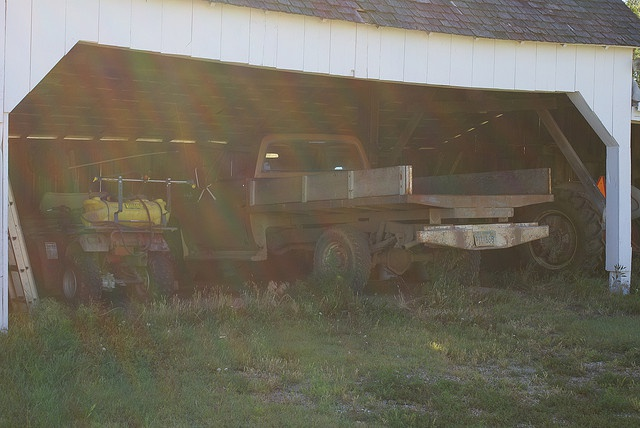Describe the objects in this image and their specific colors. I can see truck in lightgray, gray, and darkgray tones and truck in lightgray, black, and gray tones in this image. 